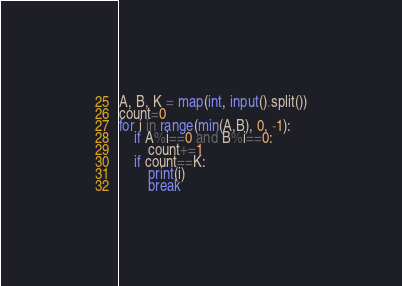<code> <loc_0><loc_0><loc_500><loc_500><_Python_>A, B, K = map(int, input().split())
count=0
for i in range(min(A,B), 0, -1):
    if A%i==0 and B%i==0:
        count+=1
    if count==K:
        print(i)
        break
</code> 